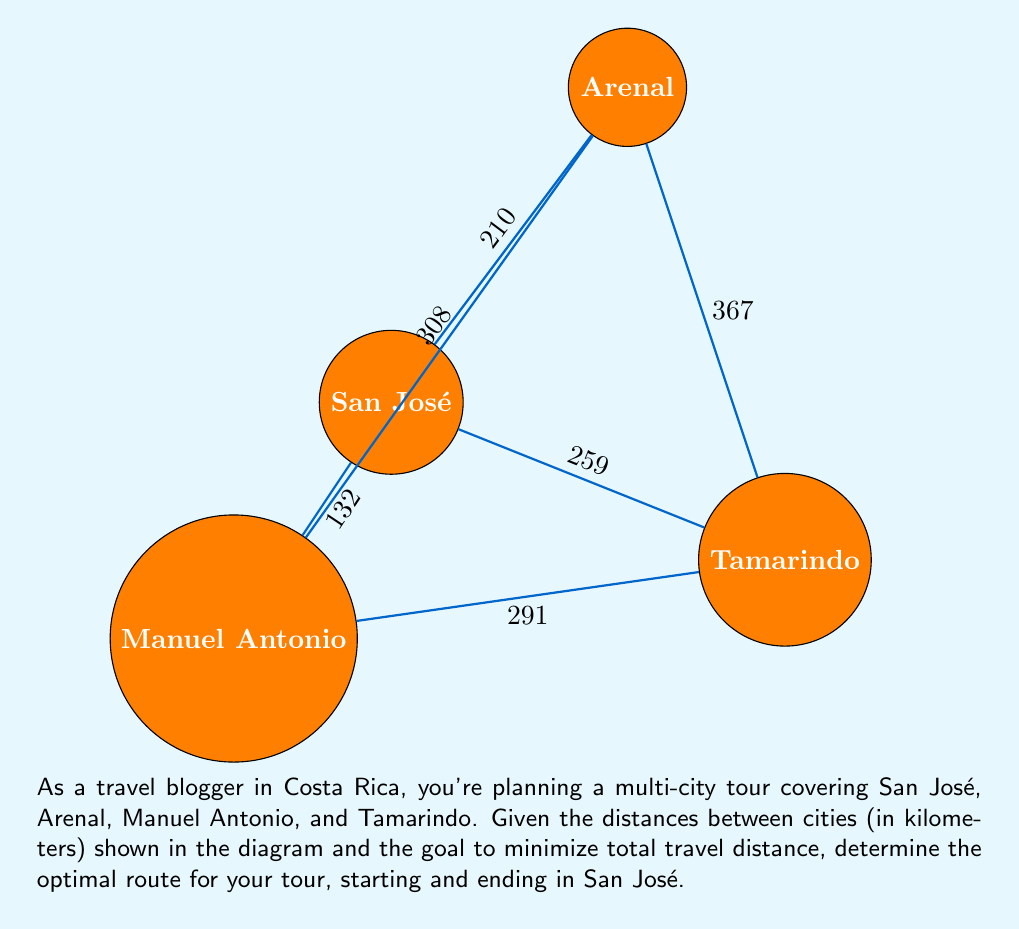Could you help me with this problem? To solve this problem, we'll use the concept of the Traveling Salesman Problem (TSP) and apply a brute-force approach due to the small number of cities.

Step 1: List all possible routes starting and ending in San José.
1. San José - Arenal - Manuel Antonio - Tamarindo - San José
2. San José - Arenal - Tamarindo - Manuel Antonio - San José
3. San José - Manuel Antonio - Arenal - Tamarindo - San José
4. San José - Manuel Antonio - Tamarindo - Arenal - San José
5. San José - Tamarindo - Arenal - Manuel Antonio - San José
6. San José - Tamarindo - Manuel Antonio - Arenal - San José

Step 2: Calculate the total distance for each route.

1. $210 + 308 + 291 + 259 = 1068$ km
2. $210 + 367 + 291 + 132 = 1000$ km
3. $132 + 308 + 367 + 259 = 1066$ km
4. $132 + 291 + 367 + 210 = 1000$ km
5. $259 + 367 + 308 + 132 = 1066$ km
6. $259 + 291 + 308 + 210 = 1068$ km

Step 3: Identify the route(s) with the minimum total distance.

The minimum distance is 1000 km, achieved by two routes:
- San José - Arenal - Tamarindo - Manuel Antonio - San José
- San José - Manuel Antonio - Tamarindo - Arenal - San José

Both routes are optimal in terms of distance. The travel blogger can choose either based on other factors like preferred direction or specific attractions along the way.
Answer: Optimal routes: San José → Arenal → Tamarindo → Manuel Antonio → San José, or San José → Manuel Antonio → Tamarindo → Arenal → San José. Total distance: 1000 km. 